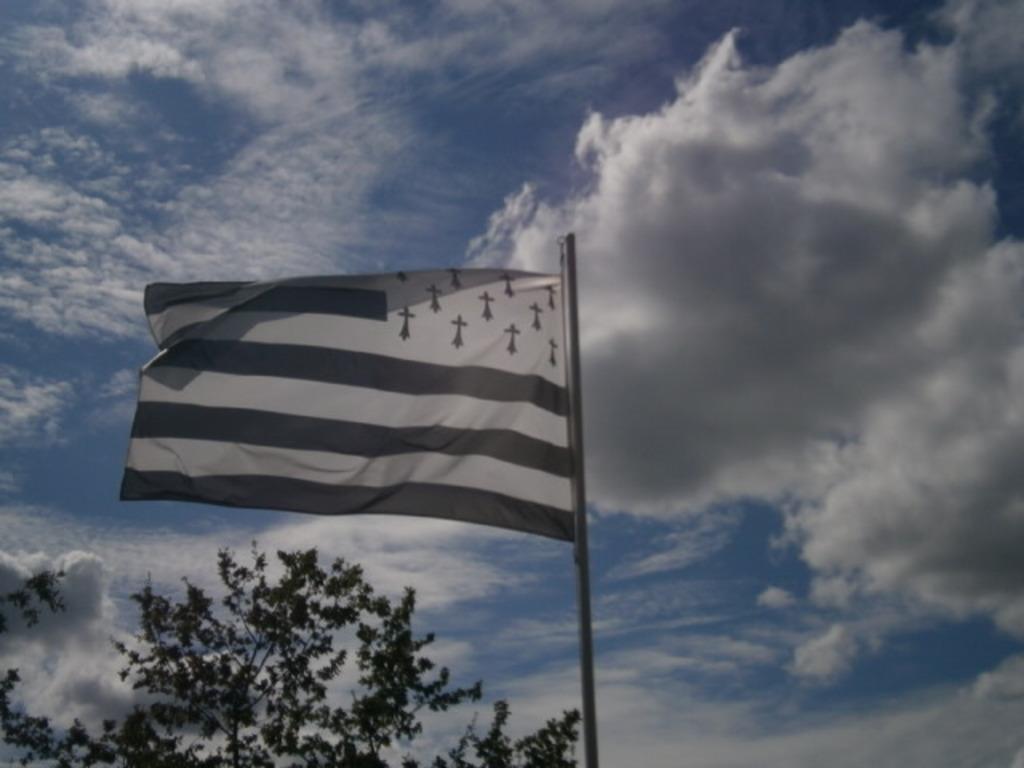How would you summarize this image in a sentence or two? In this picture there is a flag in the center of the image and there is a tree at the bottom side of the image and there is sky in the background area of the image. 